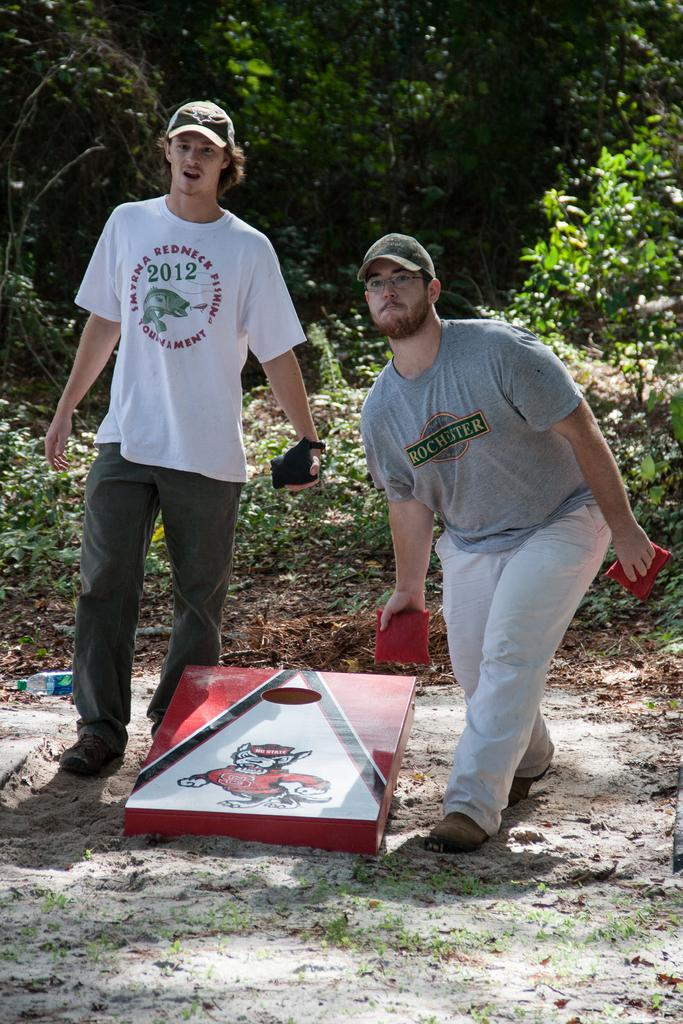What can be seen in the image? There are men standing in the image. Where are the men standing? The men are standing on the ground. What can be seen in the background of the image? There are trees and plants in the background of the image. What letters are the men holding in the image? There are no letters visible in the image; the men are not holding anything. 